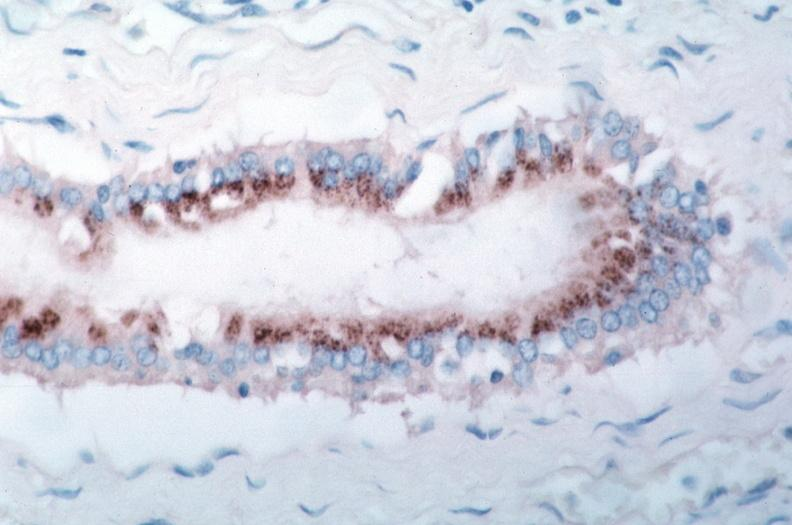s rocky mountain spotted fever, immunoperoxidase staining vessels for rickettsia rickettsii?
Answer the question using a single word or phrase. Yes 